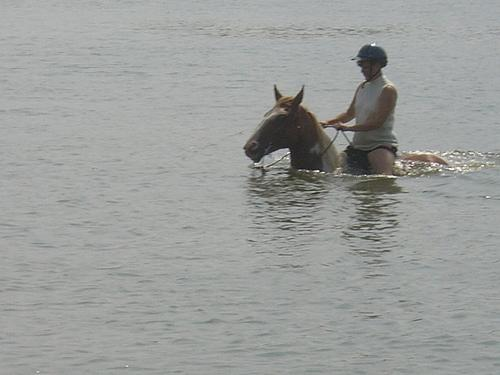Describe the main character in the image and the action they are performing. A woman wearing a helmet and riding attire is on a horse, as they wade together through water. Provide a brief description of the image, highlighting the main elements present. A woman wearing a helmet is riding a horse in water, with reflections and ripples visible around them. Provide a succinct summary of the image, emphasizing the key details and the environment. A helmeted female rider and her horse navigate through water, which reflects and ripples around them. Explain the main action taking place in the scene and the primary characters involved. A female rider in a helmet and a horse are wading through water, as ripples radiate out from them. Give a short description of the main subject in the image, along with the most noticeable details. A female rider in a blue helmet, white top, and shorts is on a horse in water, creating ripples around. Describe the scene by mentioning the main focus and their interaction with the environment. A lady in a helmet rides a horse in water, as the horse's movement creates ripples and reflections. Write a concise description of the main objects and their current state in the image. A helmeted woman on a horse traverses water, causing ripples and reflections in their surroundings. Provide an overview of the image, focusing on the primary subject and their attire. A woman in a helmet, shorts, and white shirt is riding a horse through water, both creating ripples. Write a brief summary of the image, noting the main subject and the environment they are in. A helmet-clad woman on horseback wades through water, surrounded by ripples and reflections. Explain the primary activity taking place in the picture, and describe the participants' attire. A woman wearing a blue helmet, white shirt, and shorts is riding a horse in water, generating ripples. 